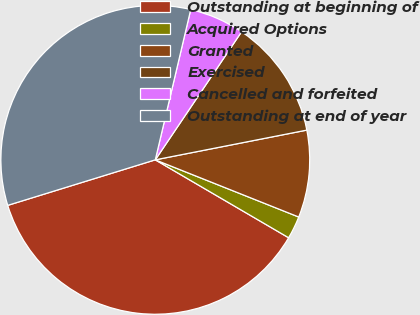Convert chart. <chart><loc_0><loc_0><loc_500><loc_500><pie_chart><fcel>Outstanding at beginning of<fcel>Acquired Options<fcel>Granted<fcel>Exercised<fcel>Cancelled and forfeited<fcel>Outstanding at end of year<nl><fcel>36.82%<fcel>2.38%<fcel>9.12%<fcel>12.48%<fcel>5.75%<fcel>33.45%<nl></chart> 